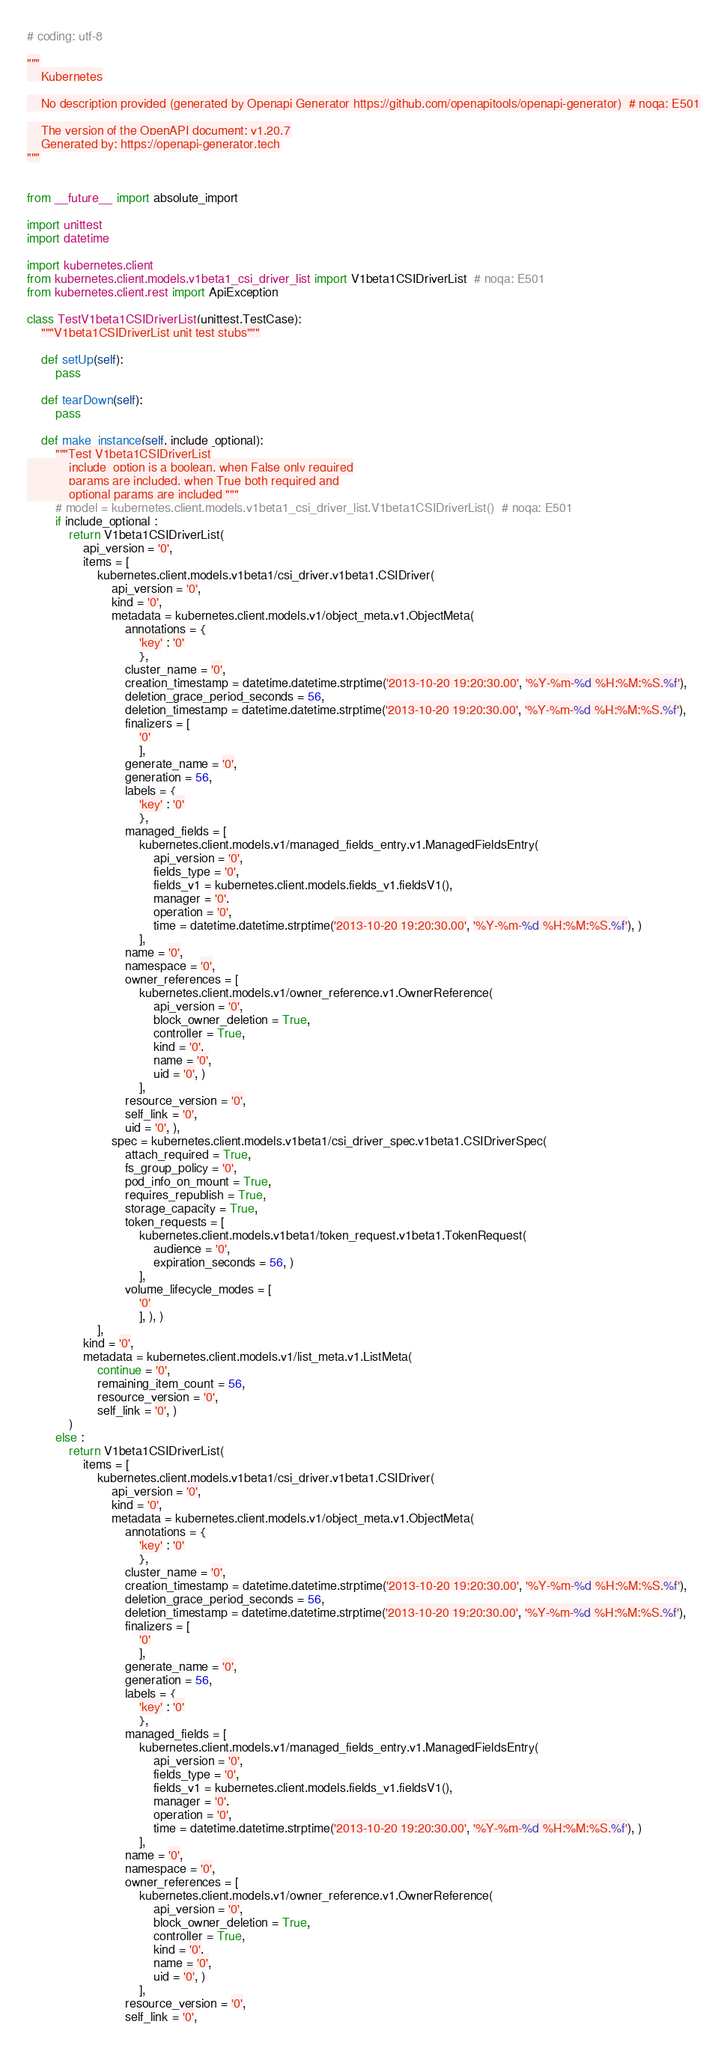Convert code to text. <code><loc_0><loc_0><loc_500><loc_500><_Python_># coding: utf-8

"""
    Kubernetes

    No description provided (generated by Openapi Generator https://github.com/openapitools/openapi-generator)  # noqa: E501

    The version of the OpenAPI document: v1.20.7
    Generated by: https://openapi-generator.tech
"""


from __future__ import absolute_import

import unittest
import datetime

import kubernetes.client
from kubernetes.client.models.v1beta1_csi_driver_list import V1beta1CSIDriverList  # noqa: E501
from kubernetes.client.rest import ApiException

class TestV1beta1CSIDriverList(unittest.TestCase):
    """V1beta1CSIDriverList unit test stubs"""

    def setUp(self):
        pass

    def tearDown(self):
        pass

    def make_instance(self, include_optional):
        """Test V1beta1CSIDriverList
            include_option is a boolean, when False only required
            params are included, when True both required and
            optional params are included """
        # model = kubernetes.client.models.v1beta1_csi_driver_list.V1beta1CSIDriverList()  # noqa: E501
        if include_optional :
            return V1beta1CSIDriverList(
                api_version = '0', 
                items = [
                    kubernetes.client.models.v1beta1/csi_driver.v1beta1.CSIDriver(
                        api_version = '0', 
                        kind = '0', 
                        metadata = kubernetes.client.models.v1/object_meta.v1.ObjectMeta(
                            annotations = {
                                'key' : '0'
                                }, 
                            cluster_name = '0', 
                            creation_timestamp = datetime.datetime.strptime('2013-10-20 19:20:30.00', '%Y-%m-%d %H:%M:%S.%f'), 
                            deletion_grace_period_seconds = 56, 
                            deletion_timestamp = datetime.datetime.strptime('2013-10-20 19:20:30.00', '%Y-%m-%d %H:%M:%S.%f'), 
                            finalizers = [
                                '0'
                                ], 
                            generate_name = '0', 
                            generation = 56, 
                            labels = {
                                'key' : '0'
                                }, 
                            managed_fields = [
                                kubernetes.client.models.v1/managed_fields_entry.v1.ManagedFieldsEntry(
                                    api_version = '0', 
                                    fields_type = '0', 
                                    fields_v1 = kubernetes.client.models.fields_v1.fieldsV1(), 
                                    manager = '0', 
                                    operation = '0', 
                                    time = datetime.datetime.strptime('2013-10-20 19:20:30.00', '%Y-%m-%d %H:%M:%S.%f'), )
                                ], 
                            name = '0', 
                            namespace = '0', 
                            owner_references = [
                                kubernetes.client.models.v1/owner_reference.v1.OwnerReference(
                                    api_version = '0', 
                                    block_owner_deletion = True, 
                                    controller = True, 
                                    kind = '0', 
                                    name = '0', 
                                    uid = '0', )
                                ], 
                            resource_version = '0', 
                            self_link = '0', 
                            uid = '0', ), 
                        spec = kubernetes.client.models.v1beta1/csi_driver_spec.v1beta1.CSIDriverSpec(
                            attach_required = True, 
                            fs_group_policy = '0', 
                            pod_info_on_mount = True, 
                            requires_republish = True, 
                            storage_capacity = True, 
                            token_requests = [
                                kubernetes.client.models.v1beta1/token_request.v1beta1.TokenRequest(
                                    audience = '0', 
                                    expiration_seconds = 56, )
                                ], 
                            volume_lifecycle_modes = [
                                '0'
                                ], ), )
                    ], 
                kind = '0', 
                metadata = kubernetes.client.models.v1/list_meta.v1.ListMeta(
                    continue = '0', 
                    remaining_item_count = 56, 
                    resource_version = '0', 
                    self_link = '0', )
            )
        else :
            return V1beta1CSIDriverList(
                items = [
                    kubernetes.client.models.v1beta1/csi_driver.v1beta1.CSIDriver(
                        api_version = '0', 
                        kind = '0', 
                        metadata = kubernetes.client.models.v1/object_meta.v1.ObjectMeta(
                            annotations = {
                                'key' : '0'
                                }, 
                            cluster_name = '0', 
                            creation_timestamp = datetime.datetime.strptime('2013-10-20 19:20:30.00', '%Y-%m-%d %H:%M:%S.%f'), 
                            deletion_grace_period_seconds = 56, 
                            deletion_timestamp = datetime.datetime.strptime('2013-10-20 19:20:30.00', '%Y-%m-%d %H:%M:%S.%f'), 
                            finalizers = [
                                '0'
                                ], 
                            generate_name = '0', 
                            generation = 56, 
                            labels = {
                                'key' : '0'
                                }, 
                            managed_fields = [
                                kubernetes.client.models.v1/managed_fields_entry.v1.ManagedFieldsEntry(
                                    api_version = '0', 
                                    fields_type = '0', 
                                    fields_v1 = kubernetes.client.models.fields_v1.fieldsV1(), 
                                    manager = '0', 
                                    operation = '0', 
                                    time = datetime.datetime.strptime('2013-10-20 19:20:30.00', '%Y-%m-%d %H:%M:%S.%f'), )
                                ], 
                            name = '0', 
                            namespace = '0', 
                            owner_references = [
                                kubernetes.client.models.v1/owner_reference.v1.OwnerReference(
                                    api_version = '0', 
                                    block_owner_deletion = True, 
                                    controller = True, 
                                    kind = '0', 
                                    name = '0', 
                                    uid = '0', )
                                ], 
                            resource_version = '0', 
                            self_link = '0', </code> 